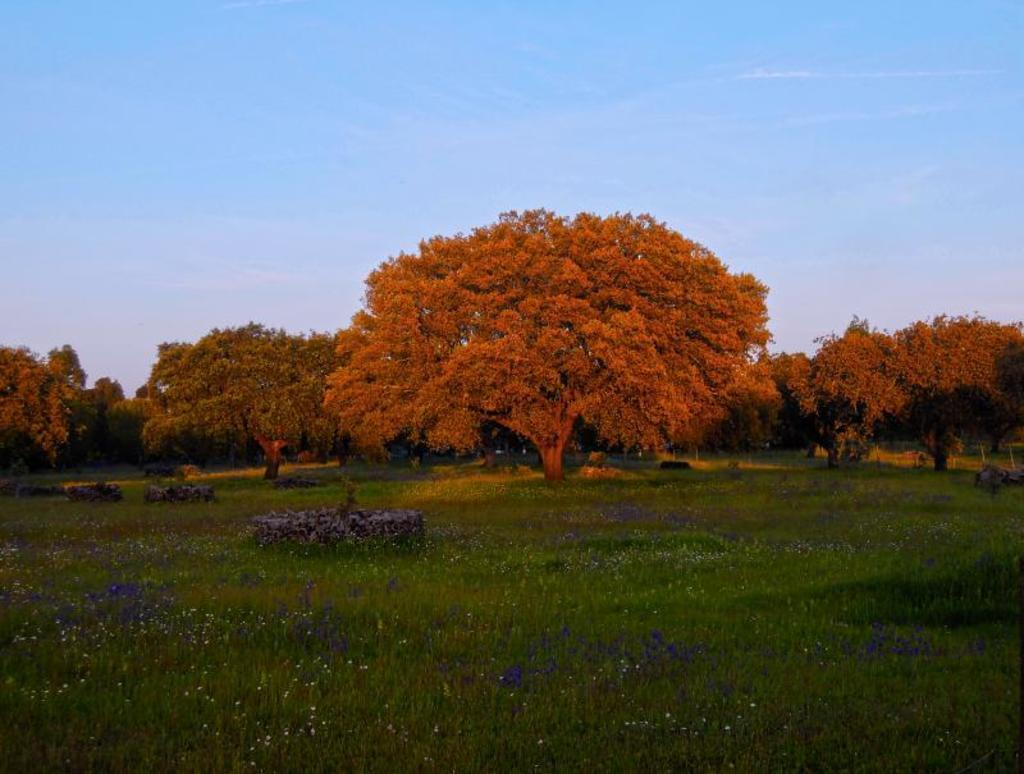What type of vegetation can be seen in the garden? There are big trees in the garden. Are there any smaller plants present in the garden? Yes, there are small plants with flowers around the trees. What is the profit generated by the discussion held under the trees in the garden? There is no mention of a discussion or profit in the image, as it only features big trees and small plants with flowers in a garden. 